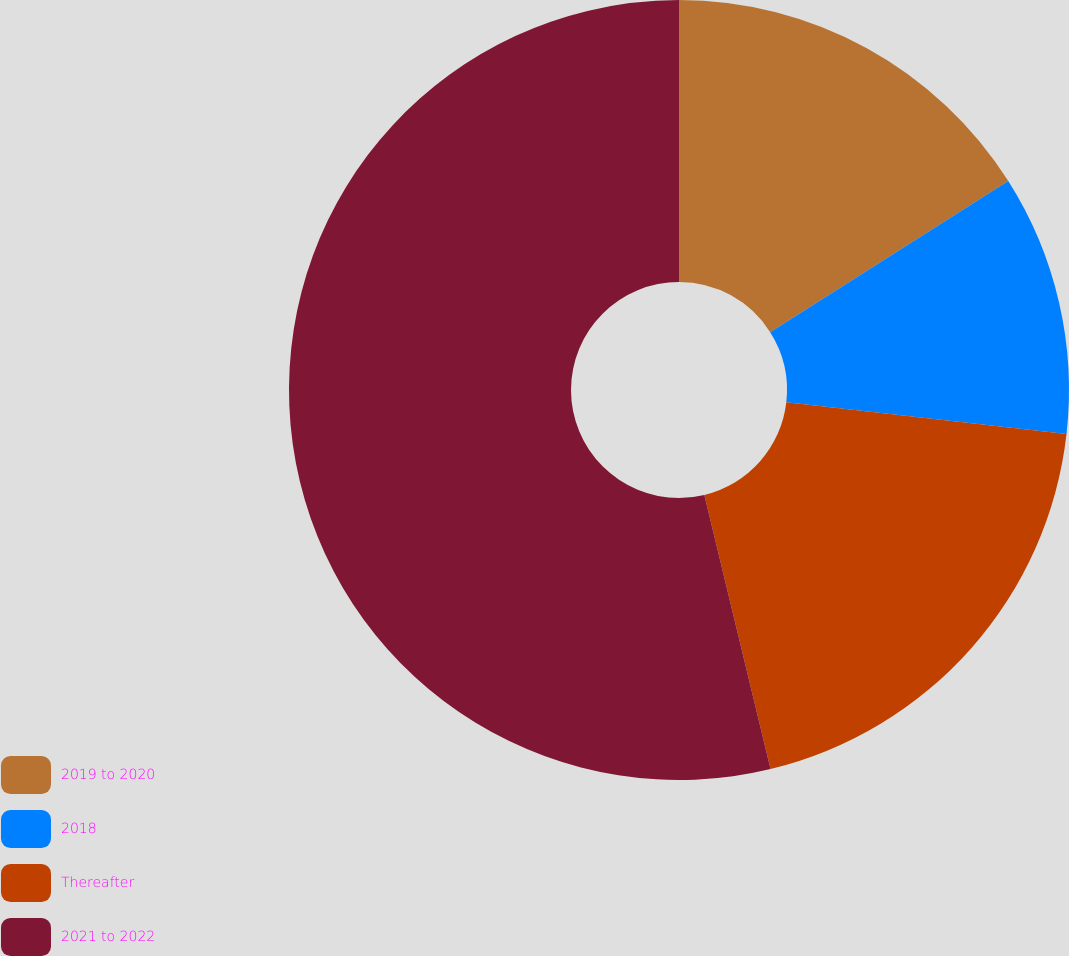Convert chart to OTSL. <chart><loc_0><loc_0><loc_500><loc_500><pie_chart><fcel>2019 to 2020<fcel>2018<fcel>Thereafter<fcel>2021 to 2022<nl><fcel>16.0%<fcel>10.8%<fcel>19.43%<fcel>53.77%<nl></chart> 